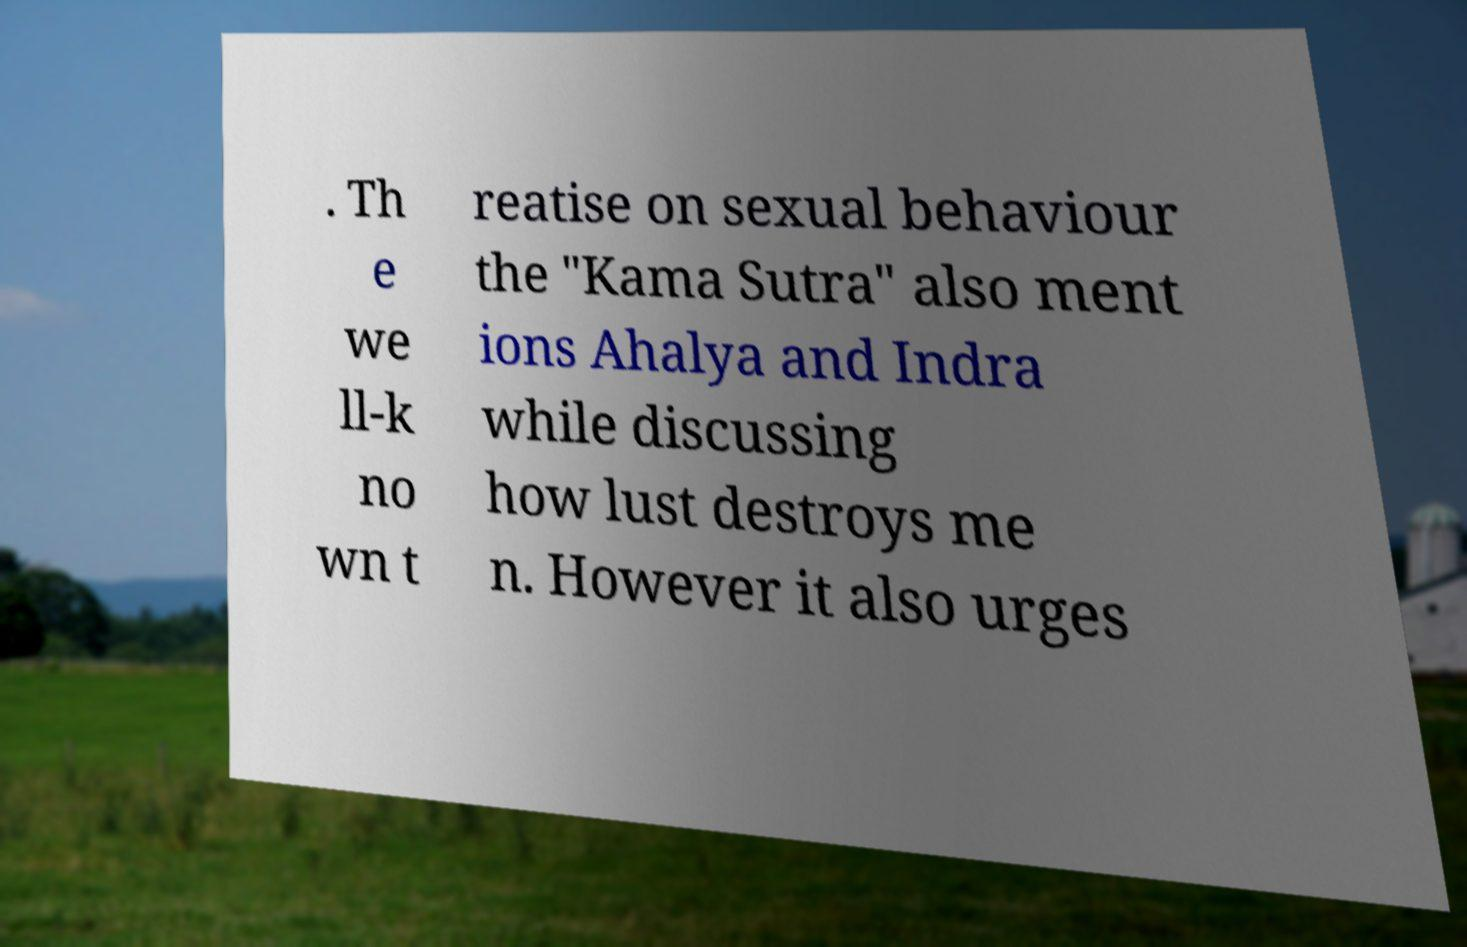Please identify and transcribe the text found in this image. . Th e we ll-k no wn t reatise on sexual behaviour the "Kama Sutra" also ment ions Ahalya and Indra while discussing how lust destroys me n. However it also urges 